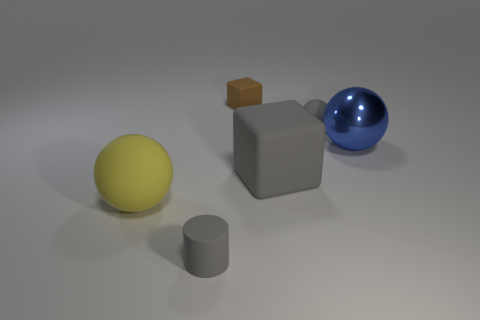There is a small matte ball; is its color the same as the small object that is in front of the large cube?
Provide a short and direct response. Yes. There is a large thing that is both left of the large blue metallic thing and right of the yellow matte sphere; what shape is it?
Your answer should be very brief. Cube. Is the number of blue metal objects that are to the right of the large yellow object less than the number of large rubber things?
Offer a very short reply. Yes. What size is the matte thing that is to the left of the matte thing that is in front of the large yellow ball?
Your response must be concise. Large. How many things are either yellow rubber objects or tiny rubber balls?
Your answer should be compact. 2. Are there any tiny rubber cylinders of the same color as the large rubber cube?
Your answer should be compact. Yes. Are there fewer yellow spheres than large green cylinders?
Provide a short and direct response. No. How many things are either big blue metallic cylinders or rubber things in front of the tiny gray rubber sphere?
Keep it short and to the point. 3. Are there any large purple objects made of the same material as the tiny gray ball?
Your answer should be very brief. No. There is another sphere that is the same size as the blue sphere; what is it made of?
Offer a terse response. Rubber. 